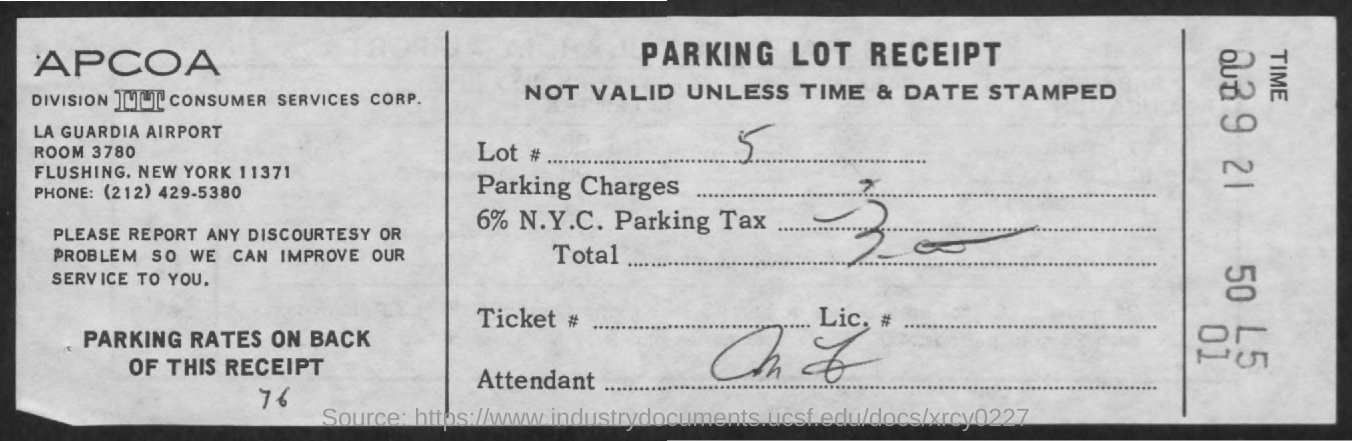Highlight a few significant elements in this photo. The document provided is a Parking Lot Receipt. The lot number given in the receipt is 5. 